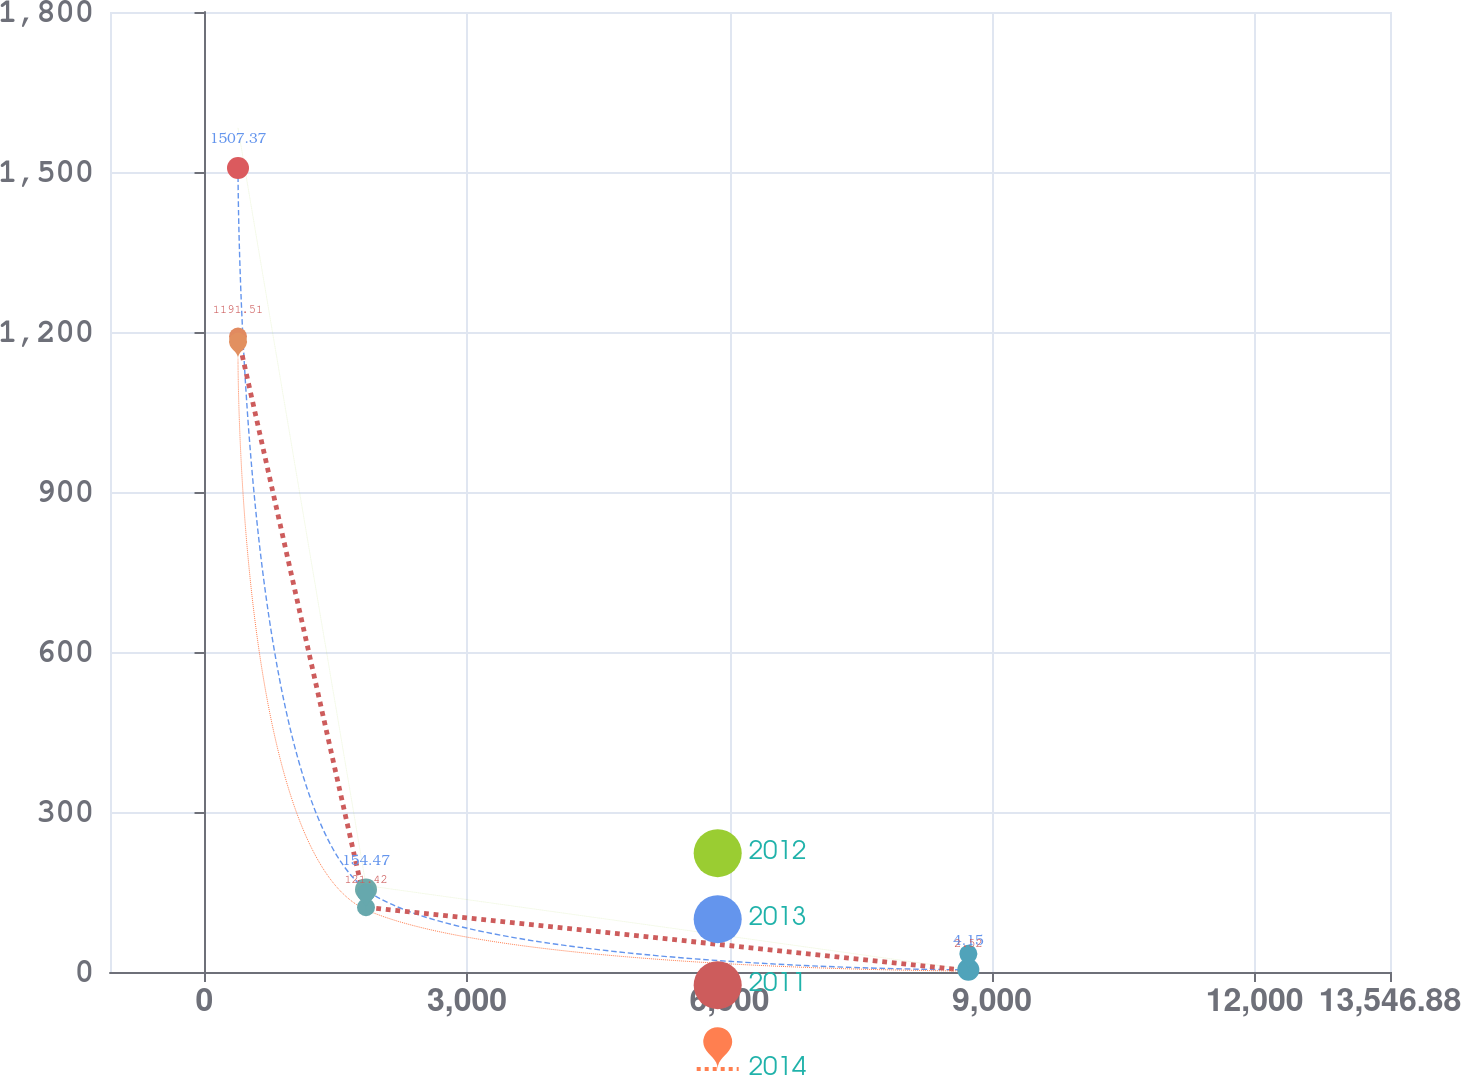Convert chart to OTSL. <chart><loc_0><loc_0><loc_500><loc_500><line_chart><ecel><fcel>2012<fcel>2013<fcel>2011<fcel>2014<nl><fcel>382.58<fcel>1582.64<fcel>1507.37<fcel>1191.51<fcel>1149.82<nl><fcel>1845.28<fcel>162.22<fcel>154.47<fcel>121.42<fcel>116.8<nl><fcel>8728.55<fcel>4.39<fcel>4.15<fcel>2.52<fcel>2.02<nl><fcel>15009.6<fcel>870.68<fcel>943.86<fcel>872.62<fcel>762.03<nl></chart> 